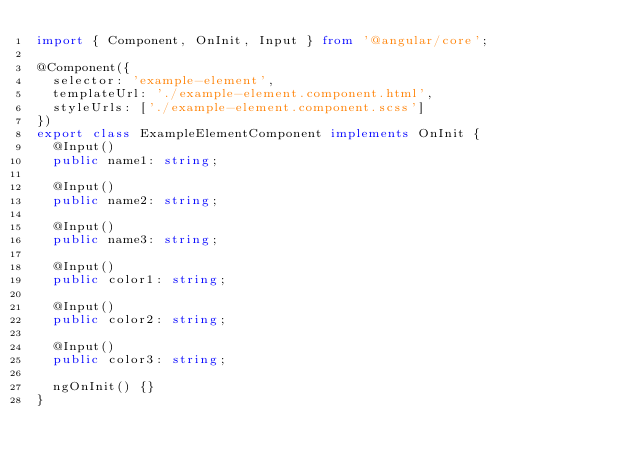<code> <loc_0><loc_0><loc_500><loc_500><_TypeScript_>import { Component, OnInit, Input } from '@angular/core';

@Component({
  selector: 'example-element',
  templateUrl: './example-element.component.html',
  styleUrls: ['./example-element.component.scss']
})
export class ExampleElementComponent implements OnInit {
  @Input()
  public name1: string;

  @Input()
  public name2: string;

  @Input()
  public name3: string;

  @Input()
  public color1: string;

  @Input()
  public color2: string;

  @Input()
  public color3: string;

  ngOnInit() {}
}
</code> 